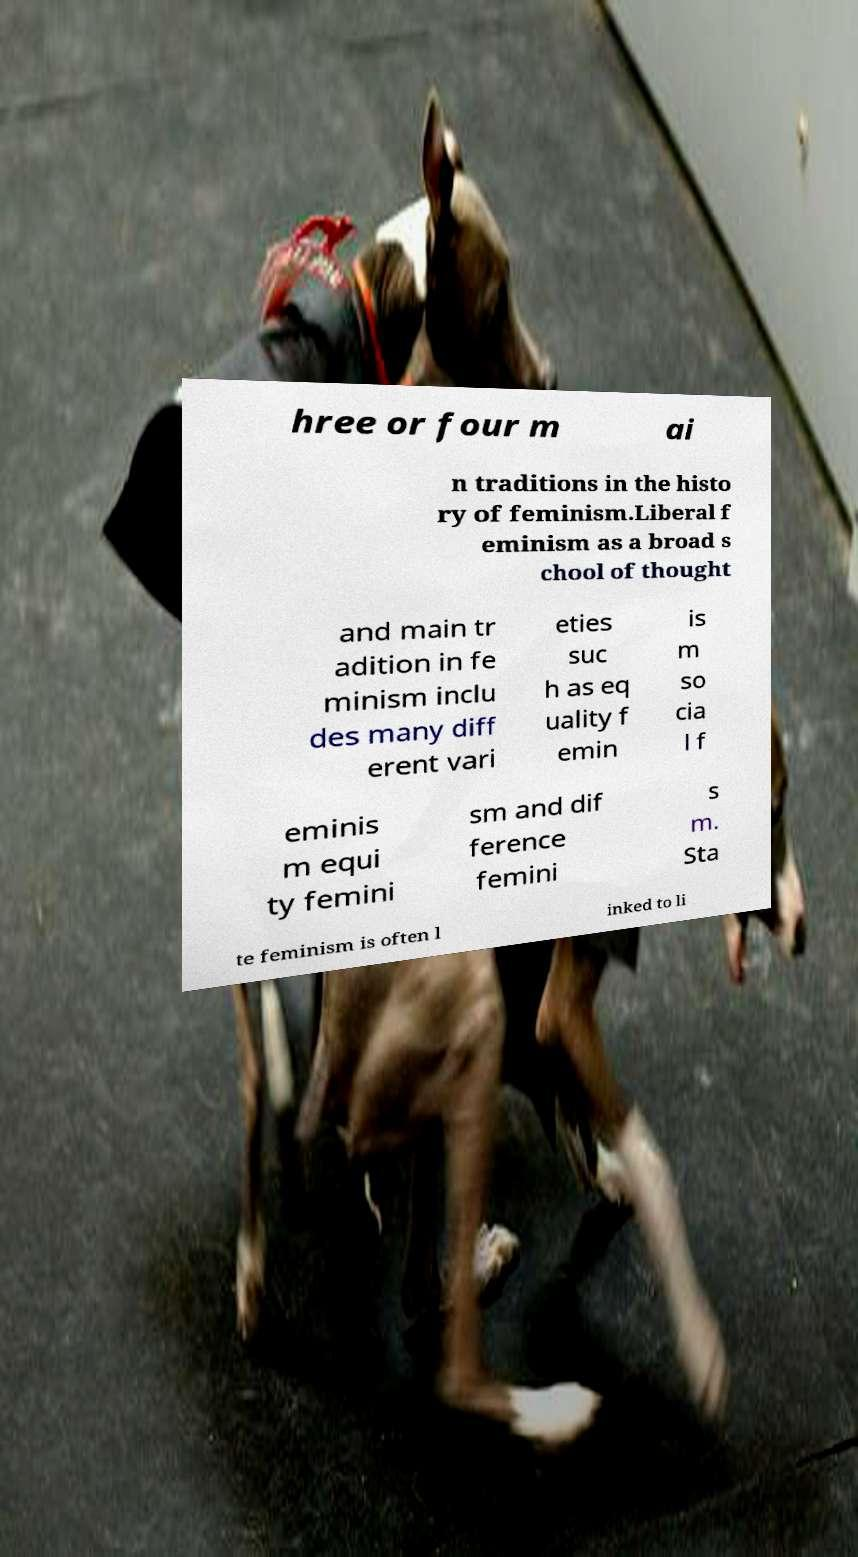For documentation purposes, I need the text within this image transcribed. Could you provide that? hree or four m ai n traditions in the histo ry of feminism.Liberal f eminism as a broad s chool of thought and main tr adition in fe minism inclu des many diff erent vari eties suc h as eq uality f emin is m so cia l f eminis m equi ty femini sm and dif ference femini s m. Sta te feminism is often l inked to li 